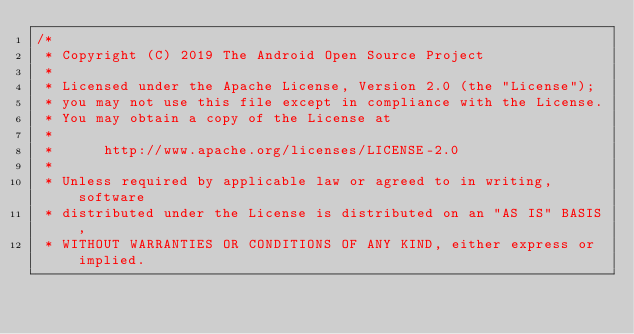Convert code to text. <code><loc_0><loc_0><loc_500><loc_500><_Java_>/*
 * Copyright (C) 2019 The Android Open Source Project
 *
 * Licensed under the Apache License, Version 2.0 (the "License");
 * you may not use this file except in compliance with the License.
 * You may obtain a copy of the License at
 *
 *      http://www.apache.org/licenses/LICENSE-2.0
 *
 * Unless required by applicable law or agreed to in writing, software
 * distributed under the License is distributed on an "AS IS" BASIS,
 * WITHOUT WARRANTIES OR CONDITIONS OF ANY KIND, either express or implied.</code> 